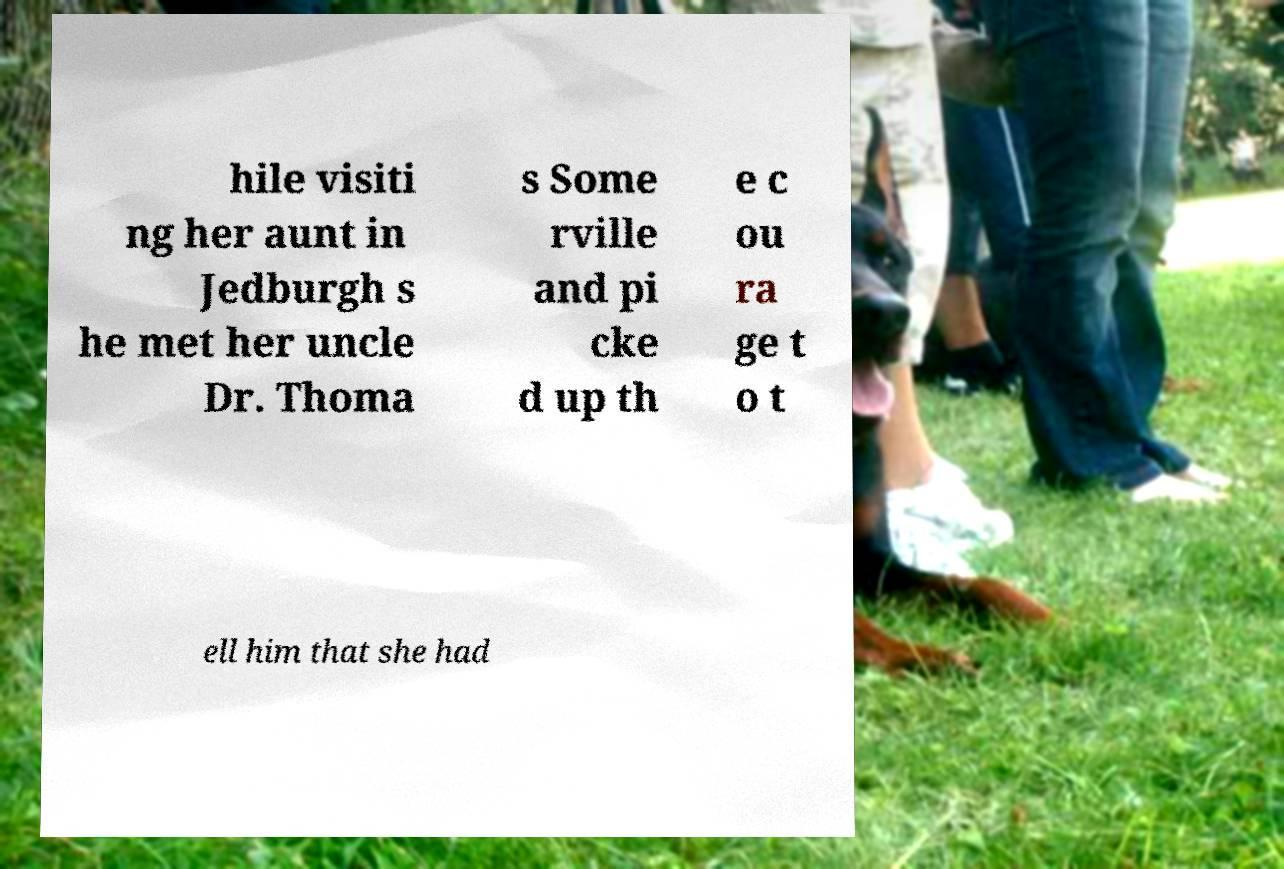What messages or text are displayed in this image? I need them in a readable, typed format. hile visiti ng her aunt in Jedburgh s he met her uncle Dr. Thoma s Some rville and pi cke d up th e c ou ra ge t o t ell him that she had 